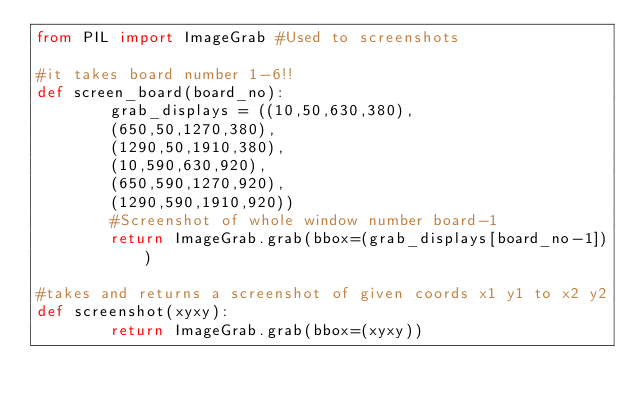Convert code to text. <code><loc_0><loc_0><loc_500><loc_500><_Python_>from PIL import ImageGrab #Used to screenshots

#it takes board number 1-6!! 
def screen_board(board_no):
        grab_displays = ((10,50,630,380),
        (650,50,1270,380),
        (1290,50,1910,380),
        (10,590,630,920),
        (650,590,1270,920),
        (1290,590,1910,920))
        #Screenshot of whole window number board-1
        return ImageGrab.grab(bbox=(grab_displays[board_no-1]))

#takes and returns a screenshot of given coords x1 y1 to x2 y2
def screenshot(xyxy): 
        return ImageGrab.grab(bbox=(xyxy))</code> 